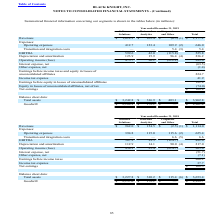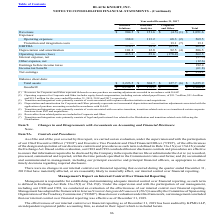According to Black Knight Financial Services's financial document, What did operating expenses for Corporate and Other include? equity-based compensation, including certain related payroll taxes. The document states: "erating expenses for Corporate and Other includes equity-based compensation, including certain related payroll taxes, of $51.7 million, $51.4 million ..." Also, Where was receivables from related parties included in? According to the financial document, Corporate and Other. The relevant text states: "Corporate and Other Total..." Also, What was the total amount of Goodwill? According to the financial document, 2,306.8 (in millions). The relevant text states: "Goodwill $ 2,134.7 $ 172.1 $ — $ 2,306.8..." Additionally, Which expenses had a total that exceeded $100 million? According to the financial document, Operating expenses. The relevant text states: "Operating expenses 388.0 113.2 68.3 (2) 569.5..." Also, can you calculate: What was the difference between the total assets and goodwill from data and analytics? Based on the calculation: 304.7-172.1, the result is 132.6 (in millions). This is based on the information: "Goodwill $ 2,189.3 $ 172.1 $ — $ 2,361.4 Total assets $ 3,223.5 $ 304.7 $ 127.7 (6) $ 3,655.9..." The key data points involved are: 172.1, 304.7. Also, can you calculate: What was the difference between Operating expenses and Revenues from Software Solutions? Based on the calculation: 904.5-388.0, the result is 516.5 (in millions). This is based on the information: "Revenues $ 904.5 $ 151.6 $ (4.5) (1) $ 1,051.6 Operating expenses 388.0 113.2 68.3 (2) 569.5..." The key data points involved are: 388.0, 904.5. 